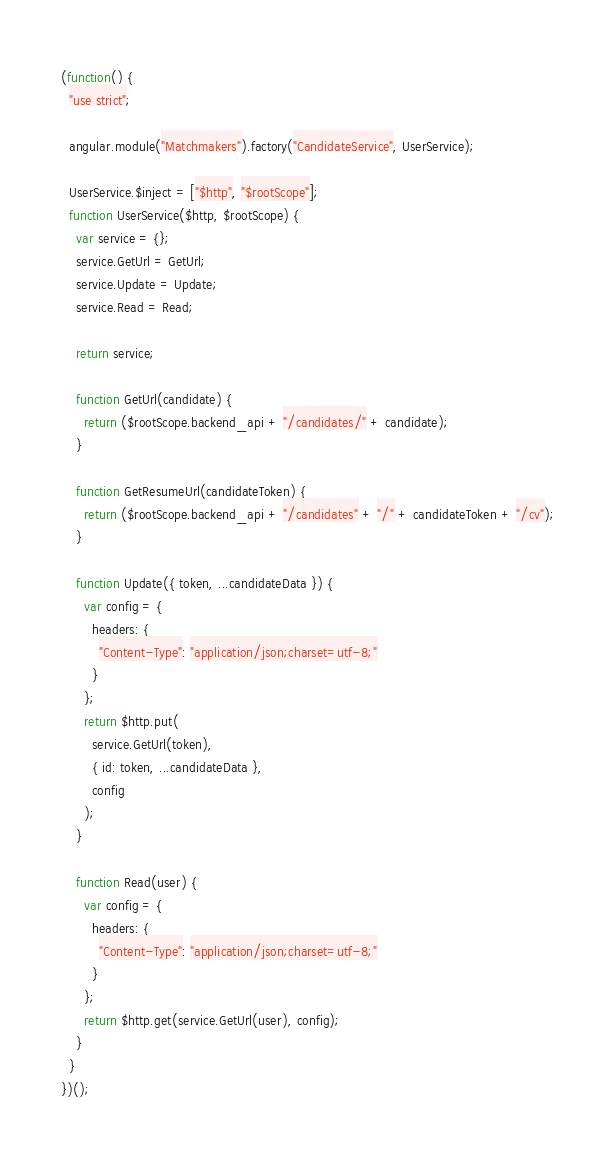<code> <loc_0><loc_0><loc_500><loc_500><_JavaScript_>(function() {
  "use strict";

  angular.module("Matchmakers").factory("CandidateService", UserService);

  UserService.$inject = ["$http", "$rootScope"];
  function UserService($http, $rootScope) {
    var service = {};
    service.GetUrl = GetUrl;
    service.Update = Update;
    service.Read = Read;

    return service;

    function GetUrl(candidate) {
      return ($rootScope.backend_api + "/candidates/" + candidate);
    }

    function GetResumeUrl(candidateToken) {
      return ($rootScope.backend_api + "/candidates" + "/" + candidateToken + "/cv");
    }

    function Update({ token, ...candidateData }) {
      var config = {
        headers: {
          "Content-Type": "application/json;charset=utf-8;"
        }
      };
      return $http.put(
        service.GetUrl(token),
        { id: token, ...candidateData },
        config
      );
    }

    function Read(user) {
      var config = {
        headers: {
          "Content-Type": "application/json;charset=utf-8;"
        }
      };
      return $http.get(service.GetUrl(user), config);
    }
  }
})();
</code> 